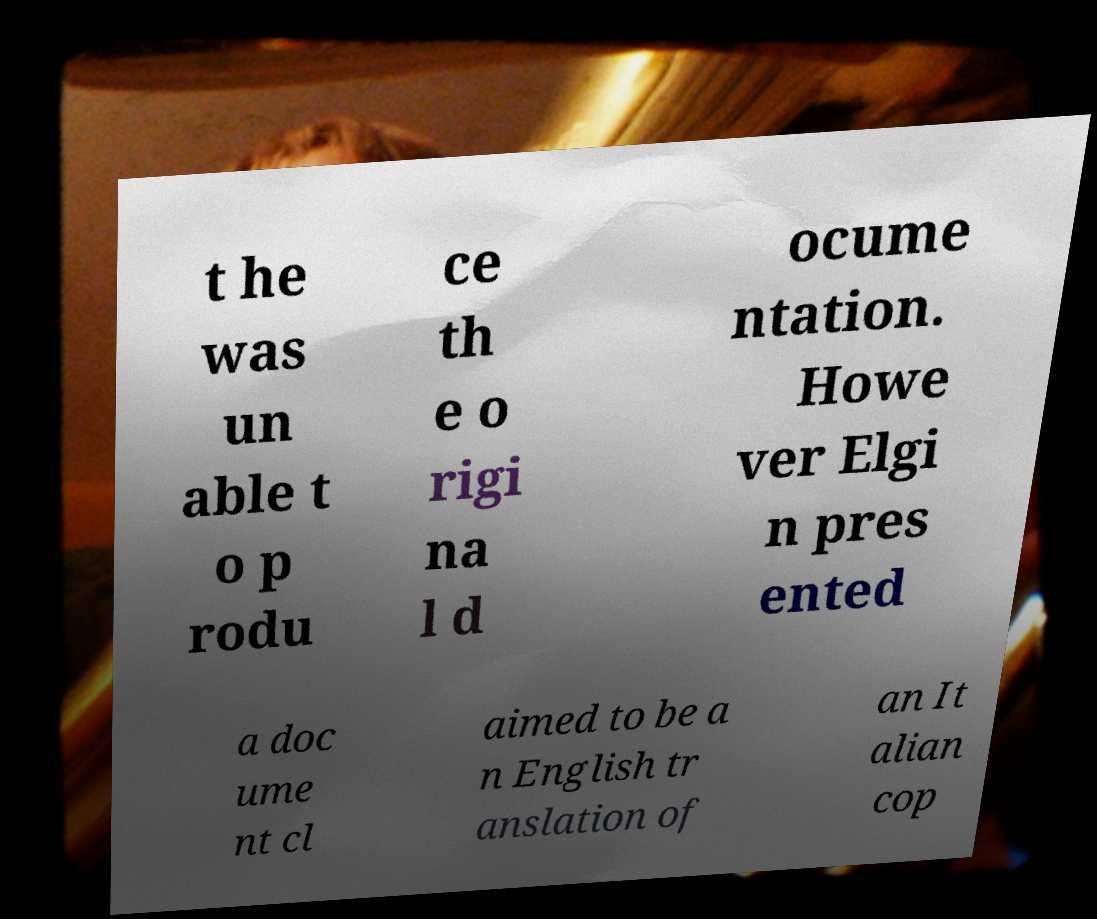Please read and relay the text visible in this image. What does it say? t he was un able t o p rodu ce th e o rigi na l d ocume ntation. Howe ver Elgi n pres ented a doc ume nt cl aimed to be a n English tr anslation of an It alian cop 